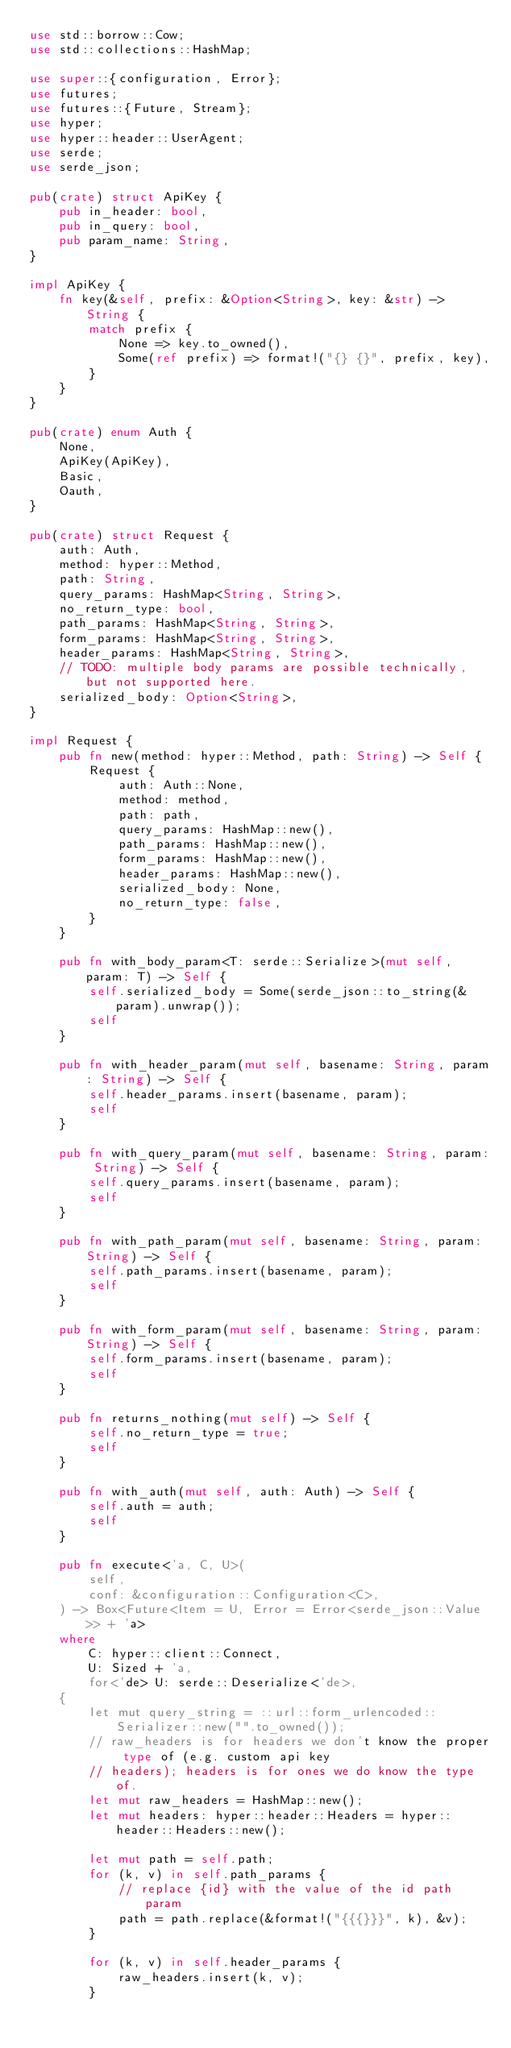Convert code to text. <code><loc_0><loc_0><loc_500><loc_500><_Rust_>use std::borrow::Cow;
use std::collections::HashMap;

use super::{configuration, Error};
use futures;
use futures::{Future, Stream};
use hyper;
use hyper::header::UserAgent;
use serde;
use serde_json;

pub(crate) struct ApiKey {
    pub in_header: bool,
    pub in_query: bool,
    pub param_name: String,
}

impl ApiKey {
    fn key(&self, prefix: &Option<String>, key: &str) -> String {
        match prefix {
            None => key.to_owned(),
            Some(ref prefix) => format!("{} {}", prefix, key),
        }
    }
}

pub(crate) enum Auth {
    None,
    ApiKey(ApiKey),
    Basic,
    Oauth,
}

pub(crate) struct Request {
    auth: Auth,
    method: hyper::Method,
    path: String,
    query_params: HashMap<String, String>,
    no_return_type: bool,
    path_params: HashMap<String, String>,
    form_params: HashMap<String, String>,
    header_params: HashMap<String, String>,
    // TODO: multiple body params are possible technically, but not supported here.
    serialized_body: Option<String>,
}

impl Request {
    pub fn new(method: hyper::Method, path: String) -> Self {
        Request {
            auth: Auth::None,
            method: method,
            path: path,
            query_params: HashMap::new(),
            path_params: HashMap::new(),
            form_params: HashMap::new(),
            header_params: HashMap::new(),
            serialized_body: None,
            no_return_type: false,
        }
    }

    pub fn with_body_param<T: serde::Serialize>(mut self, param: T) -> Self {
        self.serialized_body = Some(serde_json::to_string(&param).unwrap());
        self
    }

    pub fn with_header_param(mut self, basename: String, param: String) -> Self {
        self.header_params.insert(basename, param);
        self
    }

    pub fn with_query_param(mut self, basename: String, param: String) -> Self {
        self.query_params.insert(basename, param);
        self
    }

    pub fn with_path_param(mut self, basename: String, param: String) -> Self {
        self.path_params.insert(basename, param);
        self
    }

    pub fn with_form_param(mut self, basename: String, param: String) -> Self {
        self.form_params.insert(basename, param);
        self
    }

    pub fn returns_nothing(mut self) -> Self {
        self.no_return_type = true;
        self
    }

    pub fn with_auth(mut self, auth: Auth) -> Self {
        self.auth = auth;
        self
    }

    pub fn execute<'a, C, U>(
        self,
        conf: &configuration::Configuration<C>,
    ) -> Box<Future<Item = U, Error = Error<serde_json::Value>> + 'a>
    where
        C: hyper::client::Connect,
        U: Sized + 'a,
        for<'de> U: serde::Deserialize<'de>,
    {
        let mut query_string = ::url::form_urlencoded::Serializer::new("".to_owned());
        // raw_headers is for headers we don't know the proper type of (e.g. custom api key
        // headers); headers is for ones we do know the type of.
        let mut raw_headers = HashMap::new();
        let mut headers: hyper::header::Headers = hyper::header::Headers::new();

        let mut path = self.path;
        for (k, v) in self.path_params {
            // replace {id} with the value of the id path param
            path = path.replace(&format!("{{{}}}", k), &v);
        }

        for (k, v) in self.header_params {
            raw_headers.insert(k, v);
        }
</code> 